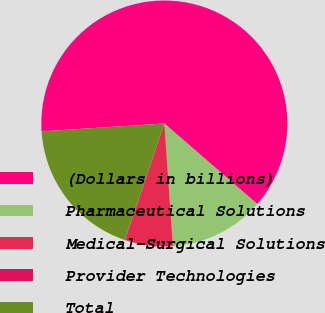<chart> <loc_0><loc_0><loc_500><loc_500><pie_chart><fcel>(Dollars in billions)<fcel>Pharmaceutical Solutions<fcel>Medical-Surgical Solutions<fcel>Provider Technologies<fcel>Total<nl><fcel>62.37%<fcel>12.52%<fcel>6.29%<fcel>0.06%<fcel>18.75%<nl></chart> 